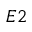<formula> <loc_0><loc_0><loc_500><loc_500>E 2</formula> 